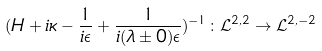<formula> <loc_0><loc_0><loc_500><loc_500>( H + i \kappa - \frac { 1 } { i \epsilon } + \frac { 1 } { i ( \lambda \pm 0 ) \epsilon } ) ^ { - 1 } \colon \mathcal { L } ^ { 2 , 2 } \rightarrow \mathcal { L } ^ { 2 , - 2 }</formula> 